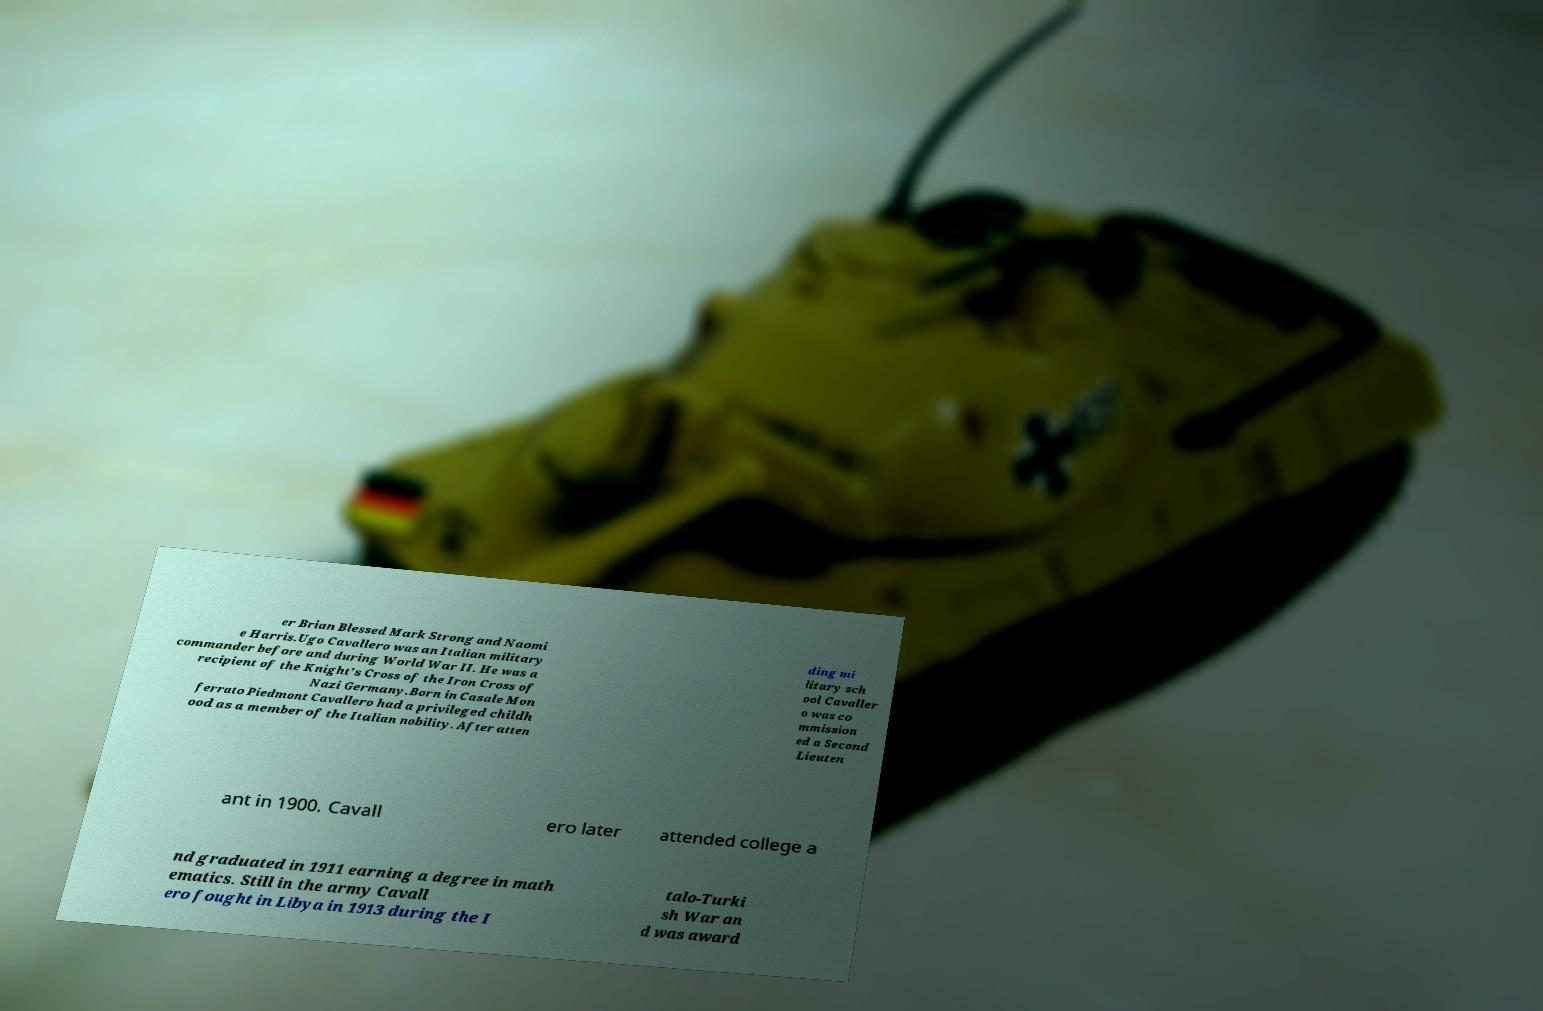Please read and relay the text visible in this image. What does it say? er Brian Blessed Mark Strong and Naomi e Harris.Ugo Cavallero was an Italian military commander before and during World War II. He was a recipient of the Knight's Cross of the Iron Cross of Nazi Germany.Born in Casale Mon ferrato Piedmont Cavallero had a privileged childh ood as a member of the Italian nobility. After atten ding mi litary sch ool Cavaller o was co mmission ed a Second Lieuten ant in 1900. Cavall ero later attended college a nd graduated in 1911 earning a degree in math ematics. Still in the army Cavall ero fought in Libya in 1913 during the I talo-Turki sh War an d was award 